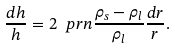Convert formula to latex. <formula><loc_0><loc_0><loc_500><loc_500>\frac { d h } { h } = 2 \ p r n { \frac { \rho _ { s } - \rho _ { l } } { \rho _ { l } } } \frac { d r } { r } .</formula> 